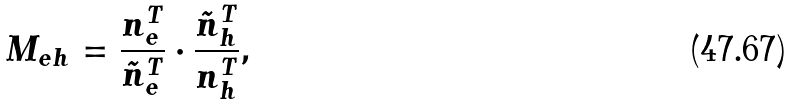<formula> <loc_0><loc_0><loc_500><loc_500>M _ { e h } = \frac { n ^ { T } _ { e } } { \tilde { n } ^ { T } _ { e } } \cdot \frac { \tilde { n } ^ { T } _ { h } } { n ^ { T } _ { h } } ,</formula> 